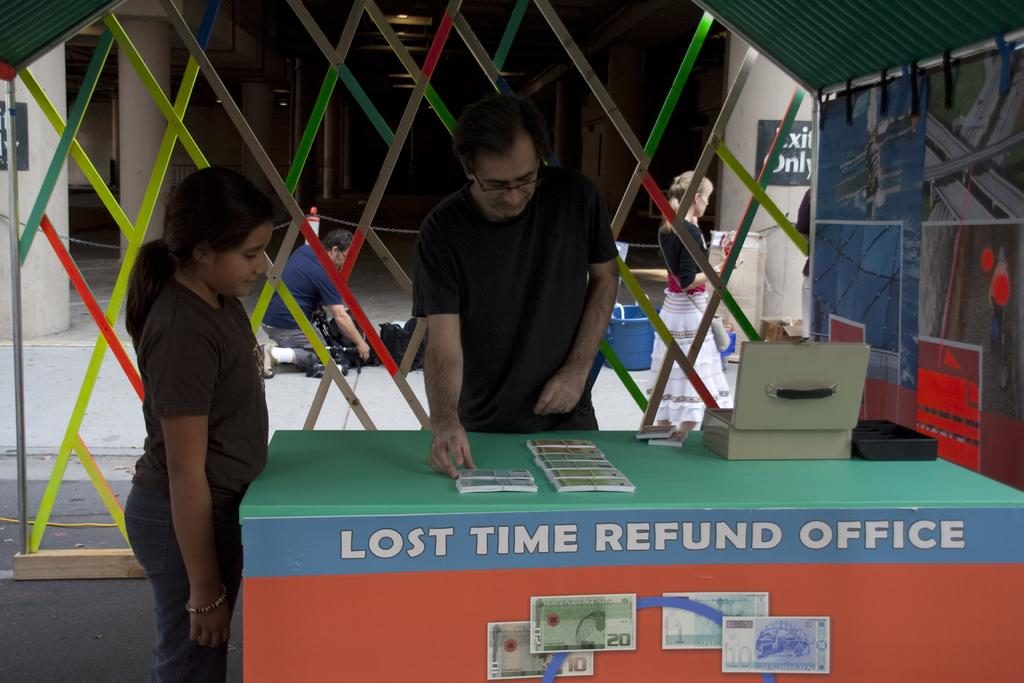What is the main subject of the image? The main subject of the image is a man. What is the man doing in the image? The man is touching an object on a table. Is there anyone else in the image besides the man? Yes, there is a girl standing beside the man. What can be seen in the background of the image? In the background of the image, there is a person and a woman walking. What type of bubble is being used for teaching in the image? There is no bubble or teaching activity present in the image. 